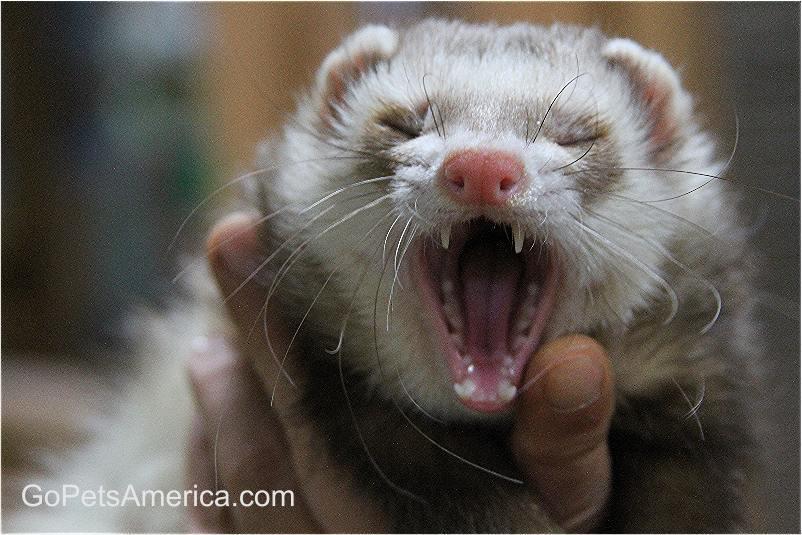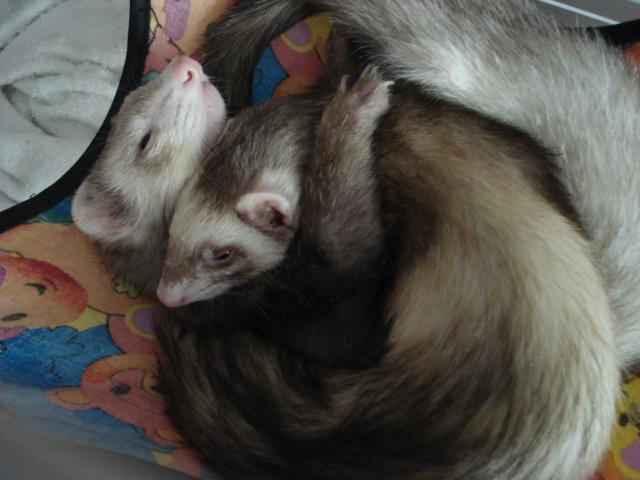The first image is the image on the left, the second image is the image on the right. Examine the images to the left and right. Is the description "In one image there is a lone ferret sleeping with its tongue sticking out." accurate? Answer yes or no. No. The first image is the image on the left, the second image is the image on the right. Analyze the images presented: Is the assertion "There are exactly three ferrets in total." valid? Answer yes or no. Yes. 